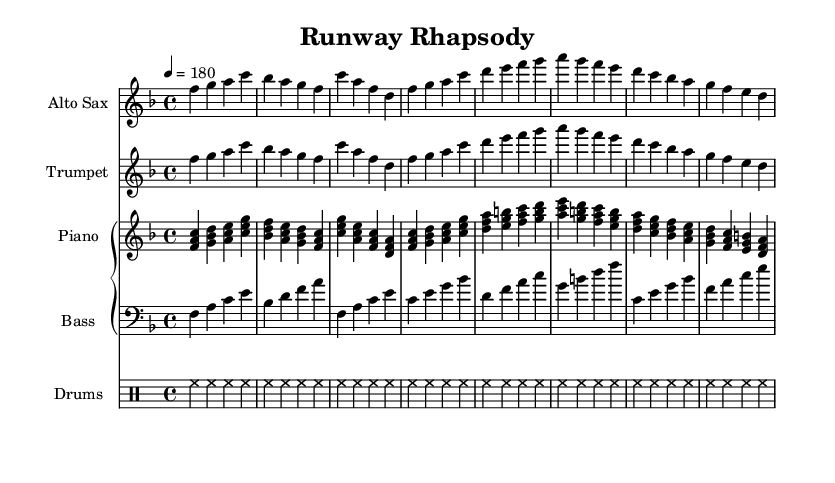What is the key signature of this music? The key signature is one flat, which indicates the piece is in F major. The presence of a flat symbol on the B line confirms this.
Answer: F major What is the time signature of this music? The time signature is indicated at the beginning as 4/4, meaning there are four beats in a measure and a quarter note gets one beat.
Answer: 4/4 What is the tempo marking of this piece? The tempo marking is set to a quarter note equals 180 beats per minute, which informs performers to play at this speed.
Answer: 180 Which instrument has the highest pitch range in this score? The Alto Saxophone typically plays in the higher pitch range compared to the other instruments such as the Trumpet and Piano, making it the highest pitch instrument in this score.
Answer: Alto Saxophone How many measures are present in the piano part? Counting the groups of four beats in the piano part shows that there are 16 measures, as it's structured in repeated sections.
Answer: 16 What is the primary mood or theme represented in this music? The title "Runway Rhapsody" suggests a celebratory or thrilling atmosphere, reflecting the excitement associated with takeoff and landing in aviation.
Answer: Celebratory What rhythmic aspect is the drum part primarily emphasizing? The drum part emphasizes a steady hi-hat rhythm throughout the piece, creating a consistent tempo and groove that supports the overall jazz feel.
Answer: Hi-hat rhythm 